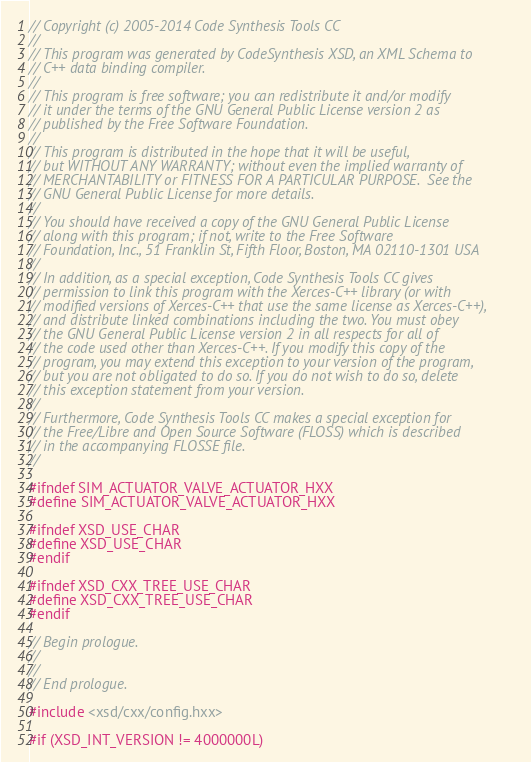<code> <loc_0><loc_0><loc_500><loc_500><_C++_>// Copyright (c) 2005-2014 Code Synthesis Tools CC
//
// This program was generated by CodeSynthesis XSD, an XML Schema to
// C++ data binding compiler.
//
// This program is free software; you can redistribute it and/or modify
// it under the terms of the GNU General Public License version 2 as
// published by the Free Software Foundation.
//
// This program is distributed in the hope that it will be useful,
// but WITHOUT ANY WARRANTY; without even the implied warranty of
// MERCHANTABILITY or FITNESS FOR A PARTICULAR PURPOSE.  See the
// GNU General Public License for more details.
//
// You should have received a copy of the GNU General Public License
// along with this program; if not, write to the Free Software
// Foundation, Inc., 51 Franklin St, Fifth Floor, Boston, MA 02110-1301 USA
//
// In addition, as a special exception, Code Synthesis Tools CC gives
// permission to link this program with the Xerces-C++ library (or with
// modified versions of Xerces-C++ that use the same license as Xerces-C++),
// and distribute linked combinations including the two. You must obey
// the GNU General Public License version 2 in all respects for all of
// the code used other than Xerces-C++. If you modify this copy of the
// program, you may extend this exception to your version of the program,
// but you are not obligated to do so. If you do not wish to do so, delete
// this exception statement from your version.
//
// Furthermore, Code Synthesis Tools CC makes a special exception for
// the Free/Libre and Open Source Software (FLOSS) which is described
// in the accompanying FLOSSE file.
//

#ifndef SIM_ACTUATOR_VALVE_ACTUATOR_HXX
#define SIM_ACTUATOR_VALVE_ACTUATOR_HXX

#ifndef XSD_USE_CHAR
#define XSD_USE_CHAR
#endif

#ifndef XSD_CXX_TREE_USE_CHAR
#define XSD_CXX_TREE_USE_CHAR
#endif

// Begin prologue.
//
//
// End prologue.

#include <xsd/cxx/config.hxx>

#if (XSD_INT_VERSION != 4000000L)</code> 